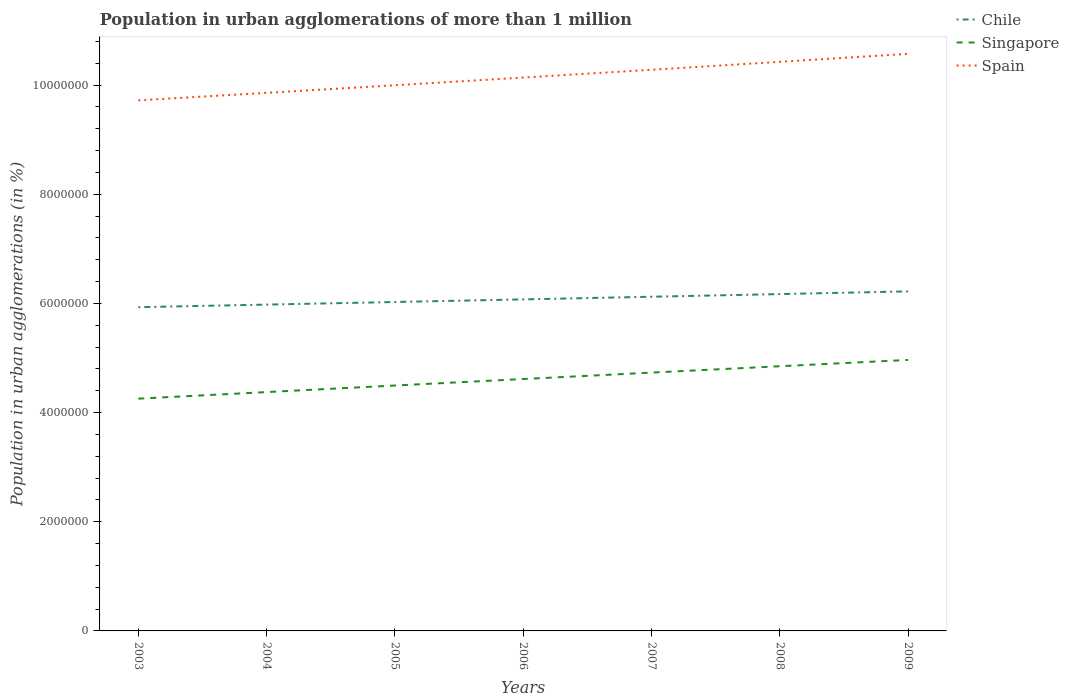How many different coloured lines are there?
Provide a succinct answer. 3. Across all years, what is the maximum population in urban agglomerations in Singapore?
Provide a succinct answer. 4.25e+06. In which year was the population in urban agglomerations in Singapore maximum?
Ensure brevity in your answer.  2003. What is the total population in urban agglomerations in Spain in the graph?
Provide a short and direct response. -5.68e+05. What is the difference between the highest and the second highest population in urban agglomerations in Spain?
Your response must be concise. 8.52e+05. What is the difference between the highest and the lowest population in urban agglomerations in Spain?
Your response must be concise. 3. Is the population in urban agglomerations in Chile strictly greater than the population in urban agglomerations in Spain over the years?
Offer a terse response. Yes. How many lines are there?
Offer a very short reply. 3. How many years are there in the graph?
Offer a very short reply. 7. What is the difference between two consecutive major ticks on the Y-axis?
Offer a very short reply. 2.00e+06. Are the values on the major ticks of Y-axis written in scientific E-notation?
Your answer should be compact. No. Does the graph contain grids?
Your answer should be very brief. No. How are the legend labels stacked?
Offer a very short reply. Vertical. What is the title of the graph?
Keep it short and to the point. Population in urban agglomerations of more than 1 million. Does "France" appear as one of the legend labels in the graph?
Offer a terse response. No. What is the label or title of the X-axis?
Offer a very short reply. Years. What is the label or title of the Y-axis?
Offer a very short reply. Population in urban agglomerations (in %). What is the Population in urban agglomerations (in %) in Chile in 2003?
Ensure brevity in your answer.  5.93e+06. What is the Population in urban agglomerations (in %) in Singapore in 2003?
Your answer should be very brief. 4.25e+06. What is the Population in urban agglomerations (in %) of Spain in 2003?
Make the answer very short. 9.72e+06. What is the Population in urban agglomerations (in %) of Chile in 2004?
Make the answer very short. 5.98e+06. What is the Population in urban agglomerations (in %) in Singapore in 2004?
Your answer should be very brief. 4.38e+06. What is the Population in urban agglomerations (in %) in Spain in 2004?
Provide a short and direct response. 9.86e+06. What is the Population in urban agglomerations (in %) of Chile in 2005?
Your answer should be very brief. 6.03e+06. What is the Population in urban agglomerations (in %) in Singapore in 2005?
Give a very brief answer. 4.50e+06. What is the Population in urban agglomerations (in %) of Spain in 2005?
Provide a succinct answer. 1.00e+07. What is the Population in urban agglomerations (in %) in Chile in 2006?
Your answer should be very brief. 6.07e+06. What is the Population in urban agglomerations (in %) in Singapore in 2006?
Keep it short and to the point. 4.61e+06. What is the Population in urban agglomerations (in %) in Spain in 2006?
Provide a succinct answer. 1.01e+07. What is the Population in urban agglomerations (in %) in Chile in 2007?
Give a very brief answer. 6.12e+06. What is the Population in urban agglomerations (in %) of Singapore in 2007?
Provide a succinct answer. 4.73e+06. What is the Population in urban agglomerations (in %) of Spain in 2007?
Your answer should be compact. 1.03e+07. What is the Population in urban agglomerations (in %) in Chile in 2008?
Provide a short and direct response. 6.17e+06. What is the Population in urban agglomerations (in %) in Singapore in 2008?
Provide a short and direct response. 4.85e+06. What is the Population in urban agglomerations (in %) in Spain in 2008?
Your answer should be very brief. 1.04e+07. What is the Population in urban agglomerations (in %) of Chile in 2009?
Provide a succinct answer. 6.22e+06. What is the Population in urban agglomerations (in %) of Singapore in 2009?
Give a very brief answer. 4.96e+06. What is the Population in urban agglomerations (in %) in Spain in 2009?
Provide a short and direct response. 1.06e+07. Across all years, what is the maximum Population in urban agglomerations (in %) of Chile?
Offer a terse response. 6.22e+06. Across all years, what is the maximum Population in urban agglomerations (in %) in Singapore?
Offer a very short reply. 4.96e+06. Across all years, what is the maximum Population in urban agglomerations (in %) in Spain?
Offer a terse response. 1.06e+07. Across all years, what is the minimum Population in urban agglomerations (in %) in Chile?
Provide a short and direct response. 5.93e+06. Across all years, what is the minimum Population in urban agglomerations (in %) in Singapore?
Offer a very short reply. 4.25e+06. Across all years, what is the minimum Population in urban agglomerations (in %) of Spain?
Offer a terse response. 9.72e+06. What is the total Population in urban agglomerations (in %) of Chile in the graph?
Offer a very short reply. 4.25e+07. What is the total Population in urban agglomerations (in %) of Singapore in the graph?
Your answer should be compact. 3.23e+07. What is the total Population in urban agglomerations (in %) of Spain in the graph?
Your answer should be compact. 7.10e+07. What is the difference between the Population in urban agglomerations (in %) in Chile in 2003 and that in 2004?
Keep it short and to the point. -4.73e+04. What is the difference between the Population in urban agglomerations (in %) in Singapore in 2003 and that in 2004?
Your answer should be compact. -1.21e+05. What is the difference between the Population in urban agglomerations (in %) in Spain in 2003 and that in 2004?
Your answer should be very brief. -1.37e+05. What is the difference between the Population in urban agglomerations (in %) of Chile in 2003 and that in 2005?
Your response must be concise. -9.49e+04. What is the difference between the Population in urban agglomerations (in %) of Singapore in 2003 and that in 2005?
Offer a terse response. -2.41e+05. What is the difference between the Population in urban agglomerations (in %) in Spain in 2003 and that in 2005?
Make the answer very short. -2.76e+05. What is the difference between the Population in urban agglomerations (in %) of Chile in 2003 and that in 2006?
Provide a short and direct response. -1.43e+05. What is the difference between the Population in urban agglomerations (in %) of Singapore in 2003 and that in 2006?
Keep it short and to the point. -3.60e+05. What is the difference between the Population in urban agglomerations (in %) in Spain in 2003 and that in 2006?
Make the answer very short. -4.17e+05. What is the difference between the Population in urban agglomerations (in %) in Chile in 2003 and that in 2007?
Offer a very short reply. -1.91e+05. What is the difference between the Population in urban agglomerations (in %) of Singapore in 2003 and that in 2007?
Your answer should be compact. -4.77e+05. What is the difference between the Population in urban agglomerations (in %) in Spain in 2003 and that in 2007?
Offer a terse response. -5.60e+05. What is the difference between the Population in urban agglomerations (in %) of Chile in 2003 and that in 2008?
Keep it short and to the point. -2.40e+05. What is the difference between the Population in urban agglomerations (in %) in Singapore in 2003 and that in 2008?
Offer a terse response. -5.94e+05. What is the difference between the Population in urban agglomerations (in %) of Spain in 2003 and that in 2008?
Keep it short and to the point. -7.05e+05. What is the difference between the Population in urban agglomerations (in %) of Chile in 2003 and that in 2009?
Ensure brevity in your answer.  -2.89e+05. What is the difference between the Population in urban agglomerations (in %) in Singapore in 2003 and that in 2009?
Keep it short and to the point. -7.10e+05. What is the difference between the Population in urban agglomerations (in %) in Spain in 2003 and that in 2009?
Your response must be concise. -8.52e+05. What is the difference between the Population in urban agglomerations (in %) in Chile in 2004 and that in 2005?
Your answer should be very brief. -4.76e+04. What is the difference between the Population in urban agglomerations (in %) of Singapore in 2004 and that in 2005?
Keep it short and to the point. -1.20e+05. What is the difference between the Population in urban agglomerations (in %) of Spain in 2004 and that in 2005?
Give a very brief answer. -1.39e+05. What is the difference between the Population in urban agglomerations (in %) in Chile in 2004 and that in 2006?
Your answer should be very brief. -9.56e+04. What is the difference between the Population in urban agglomerations (in %) of Singapore in 2004 and that in 2006?
Give a very brief answer. -2.39e+05. What is the difference between the Population in urban agglomerations (in %) of Spain in 2004 and that in 2006?
Offer a terse response. -2.80e+05. What is the difference between the Population in urban agglomerations (in %) of Chile in 2004 and that in 2007?
Offer a very short reply. -1.44e+05. What is the difference between the Population in urban agglomerations (in %) of Singapore in 2004 and that in 2007?
Keep it short and to the point. -3.57e+05. What is the difference between the Population in urban agglomerations (in %) in Spain in 2004 and that in 2007?
Offer a very short reply. -4.23e+05. What is the difference between the Population in urban agglomerations (in %) in Chile in 2004 and that in 2008?
Keep it short and to the point. -1.93e+05. What is the difference between the Population in urban agglomerations (in %) in Singapore in 2004 and that in 2008?
Make the answer very short. -4.73e+05. What is the difference between the Population in urban agglomerations (in %) of Spain in 2004 and that in 2008?
Provide a succinct answer. -5.68e+05. What is the difference between the Population in urban agglomerations (in %) of Chile in 2004 and that in 2009?
Offer a terse response. -2.42e+05. What is the difference between the Population in urban agglomerations (in %) in Singapore in 2004 and that in 2009?
Your answer should be compact. -5.89e+05. What is the difference between the Population in urban agglomerations (in %) in Spain in 2004 and that in 2009?
Ensure brevity in your answer.  -7.15e+05. What is the difference between the Population in urban agglomerations (in %) of Chile in 2005 and that in 2006?
Provide a succinct answer. -4.80e+04. What is the difference between the Population in urban agglomerations (in %) in Singapore in 2005 and that in 2006?
Offer a terse response. -1.19e+05. What is the difference between the Population in urban agglomerations (in %) in Spain in 2005 and that in 2006?
Provide a short and direct response. -1.41e+05. What is the difference between the Population in urban agglomerations (in %) of Chile in 2005 and that in 2007?
Your answer should be compact. -9.64e+04. What is the difference between the Population in urban agglomerations (in %) of Singapore in 2005 and that in 2007?
Your answer should be compact. -2.37e+05. What is the difference between the Population in urban agglomerations (in %) in Spain in 2005 and that in 2007?
Your answer should be very brief. -2.84e+05. What is the difference between the Population in urban agglomerations (in %) of Chile in 2005 and that in 2008?
Keep it short and to the point. -1.45e+05. What is the difference between the Population in urban agglomerations (in %) of Singapore in 2005 and that in 2008?
Make the answer very short. -3.53e+05. What is the difference between the Population in urban agglomerations (in %) of Spain in 2005 and that in 2008?
Provide a succinct answer. -4.29e+05. What is the difference between the Population in urban agglomerations (in %) of Chile in 2005 and that in 2009?
Give a very brief answer. -1.94e+05. What is the difference between the Population in urban agglomerations (in %) of Singapore in 2005 and that in 2009?
Provide a succinct answer. -4.69e+05. What is the difference between the Population in urban agglomerations (in %) in Spain in 2005 and that in 2009?
Offer a very short reply. -5.76e+05. What is the difference between the Population in urban agglomerations (in %) in Chile in 2006 and that in 2007?
Ensure brevity in your answer.  -4.84e+04. What is the difference between the Population in urban agglomerations (in %) of Singapore in 2006 and that in 2007?
Offer a terse response. -1.18e+05. What is the difference between the Population in urban agglomerations (in %) of Spain in 2006 and that in 2007?
Your answer should be compact. -1.43e+05. What is the difference between the Population in urban agglomerations (in %) in Chile in 2006 and that in 2008?
Provide a short and direct response. -9.73e+04. What is the difference between the Population in urban agglomerations (in %) in Singapore in 2006 and that in 2008?
Make the answer very short. -2.34e+05. What is the difference between the Population in urban agglomerations (in %) of Spain in 2006 and that in 2008?
Provide a succinct answer. -2.88e+05. What is the difference between the Population in urban agglomerations (in %) of Chile in 2006 and that in 2009?
Provide a succinct answer. -1.46e+05. What is the difference between the Population in urban agglomerations (in %) of Singapore in 2006 and that in 2009?
Make the answer very short. -3.50e+05. What is the difference between the Population in urban agglomerations (in %) in Spain in 2006 and that in 2009?
Your response must be concise. -4.35e+05. What is the difference between the Population in urban agglomerations (in %) in Chile in 2007 and that in 2008?
Offer a very short reply. -4.89e+04. What is the difference between the Population in urban agglomerations (in %) in Singapore in 2007 and that in 2008?
Provide a succinct answer. -1.17e+05. What is the difference between the Population in urban agglomerations (in %) in Spain in 2007 and that in 2008?
Your response must be concise. -1.45e+05. What is the difference between the Population in urban agglomerations (in %) in Chile in 2007 and that in 2009?
Your answer should be very brief. -9.80e+04. What is the difference between the Population in urban agglomerations (in %) of Singapore in 2007 and that in 2009?
Keep it short and to the point. -2.32e+05. What is the difference between the Population in urban agglomerations (in %) of Spain in 2007 and that in 2009?
Your answer should be compact. -2.92e+05. What is the difference between the Population in urban agglomerations (in %) of Chile in 2008 and that in 2009?
Ensure brevity in your answer.  -4.91e+04. What is the difference between the Population in urban agglomerations (in %) in Singapore in 2008 and that in 2009?
Ensure brevity in your answer.  -1.16e+05. What is the difference between the Population in urban agglomerations (in %) in Spain in 2008 and that in 2009?
Make the answer very short. -1.47e+05. What is the difference between the Population in urban agglomerations (in %) of Chile in 2003 and the Population in urban agglomerations (in %) of Singapore in 2004?
Your answer should be compact. 1.56e+06. What is the difference between the Population in urban agglomerations (in %) of Chile in 2003 and the Population in urban agglomerations (in %) of Spain in 2004?
Ensure brevity in your answer.  -3.93e+06. What is the difference between the Population in urban agglomerations (in %) of Singapore in 2003 and the Population in urban agglomerations (in %) of Spain in 2004?
Offer a terse response. -5.60e+06. What is the difference between the Population in urban agglomerations (in %) of Chile in 2003 and the Population in urban agglomerations (in %) of Singapore in 2005?
Keep it short and to the point. 1.43e+06. What is the difference between the Population in urban agglomerations (in %) in Chile in 2003 and the Population in urban agglomerations (in %) in Spain in 2005?
Your response must be concise. -4.07e+06. What is the difference between the Population in urban agglomerations (in %) in Singapore in 2003 and the Population in urban agglomerations (in %) in Spain in 2005?
Provide a succinct answer. -5.74e+06. What is the difference between the Population in urban agglomerations (in %) of Chile in 2003 and the Population in urban agglomerations (in %) of Singapore in 2006?
Your response must be concise. 1.32e+06. What is the difference between the Population in urban agglomerations (in %) in Chile in 2003 and the Population in urban agglomerations (in %) in Spain in 2006?
Give a very brief answer. -4.21e+06. What is the difference between the Population in urban agglomerations (in %) in Singapore in 2003 and the Population in urban agglomerations (in %) in Spain in 2006?
Offer a terse response. -5.88e+06. What is the difference between the Population in urban agglomerations (in %) of Chile in 2003 and the Population in urban agglomerations (in %) of Singapore in 2007?
Offer a very short reply. 1.20e+06. What is the difference between the Population in urban agglomerations (in %) of Chile in 2003 and the Population in urban agglomerations (in %) of Spain in 2007?
Make the answer very short. -4.35e+06. What is the difference between the Population in urban agglomerations (in %) of Singapore in 2003 and the Population in urban agglomerations (in %) of Spain in 2007?
Keep it short and to the point. -6.02e+06. What is the difference between the Population in urban agglomerations (in %) in Chile in 2003 and the Population in urban agglomerations (in %) in Singapore in 2008?
Your answer should be very brief. 1.08e+06. What is the difference between the Population in urban agglomerations (in %) in Chile in 2003 and the Population in urban agglomerations (in %) in Spain in 2008?
Your answer should be very brief. -4.49e+06. What is the difference between the Population in urban agglomerations (in %) in Singapore in 2003 and the Population in urban agglomerations (in %) in Spain in 2008?
Give a very brief answer. -6.17e+06. What is the difference between the Population in urban agglomerations (in %) of Chile in 2003 and the Population in urban agglomerations (in %) of Singapore in 2009?
Provide a succinct answer. 9.66e+05. What is the difference between the Population in urban agglomerations (in %) in Chile in 2003 and the Population in urban agglomerations (in %) in Spain in 2009?
Offer a terse response. -4.64e+06. What is the difference between the Population in urban agglomerations (in %) of Singapore in 2003 and the Population in urban agglomerations (in %) of Spain in 2009?
Offer a terse response. -6.32e+06. What is the difference between the Population in urban agglomerations (in %) of Chile in 2004 and the Population in urban agglomerations (in %) of Singapore in 2005?
Provide a succinct answer. 1.48e+06. What is the difference between the Population in urban agglomerations (in %) in Chile in 2004 and the Population in urban agglomerations (in %) in Spain in 2005?
Ensure brevity in your answer.  -4.02e+06. What is the difference between the Population in urban agglomerations (in %) in Singapore in 2004 and the Population in urban agglomerations (in %) in Spain in 2005?
Your answer should be very brief. -5.62e+06. What is the difference between the Population in urban agglomerations (in %) of Chile in 2004 and the Population in urban agglomerations (in %) of Singapore in 2006?
Make the answer very short. 1.36e+06. What is the difference between the Population in urban agglomerations (in %) in Chile in 2004 and the Population in urban agglomerations (in %) in Spain in 2006?
Provide a succinct answer. -4.16e+06. What is the difference between the Population in urban agglomerations (in %) in Singapore in 2004 and the Population in urban agglomerations (in %) in Spain in 2006?
Ensure brevity in your answer.  -5.76e+06. What is the difference between the Population in urban agglomerations (in %) of Chile in 2004 and the Population in urban agglomerations (in %) of Singapore in 2007?
Offer a very short reply. 1.25e+06. What is the difference between the Population in urban agglomerations (in %) of Chile in 2004 and the Population in urban agglomerations (in %) of Spain in 2007?
Provide a succinct answer. -4.30e+06. What is the difference between the Population in urban agglomerations (in %) of Singapore in 2004 and the Population in urban agglomerations (in %) of Spain in 2007?
Ensure brevity in your answer.  -5.90e+06. What is the difference between the Population in urban agglomerations (in %) of Chile in 2004 and the Population in urban agglomerations (in %) of Singapore in 2008?
Make the answer very short. 1.13e+06. What is the difference between the Population in urban agglomerations (in %) of Chile in 2004 and the Population in urban agglomerations (in %) of Spain in 2008?
Your response must be concise. -4.45e+06. What is the difference between the Population in urban agglomerations (in %) in Singapore in 2004 and the Population in urban agglomerations (in %) in Spain in 2008?
Offer a very short reply. -6.05e+06. What is the difference between the Population in urban agglomerations (in %) in Chile in 2004 and the Population in urban agglomerations (in %) in Singapore in 2009?
Your response must be concise. 1.01e+06. What is the difference between the Population in urban agglomerations (in %) of Chile in 2004 and the Population in urban agglomerations (in %) of Spain in 2009?
Make the answer very short. -4.59e+06. What is the difference between the Population in urban agglomerations (in %) in Singapore in 2004 and the Population in urban agglomerations (in %) in Spain in 2009?
Keep it short and to the point. -6.20e+06. What is the difference between the Population in urban agglomerations (in %) in Chile in 2005 and the Population in urban agglomerations (in %) in Singapore in 2006?
Keep it short and to the point. 1.41e+06. What is the difference between the Population in urban agglomerations (in %) of Chile in 2005 and the Population in urban agglomerations (in %) of Spain in 2006?
Offer a terse response. -4.11e+06. What is the difference between the Population in urban agglomerations (in %) in Singapore in 2005 and the Population in urban agglomerations (in %) in Spain in 2006?
Ensure brevity in your answer.  -5.64e+06. What is the difference between the Population in urban agglomerations (in %) of Chile in 2005 and the Population in urban agglomerations (in %) of Singapore in 2007?
Provide a short and direct response. 1.29e+06. What is the difference between the Population in urban agglomerations (in %) of Chile in 2005 and the Population in urban agglomerations (in %) of Spain in 2007?
Offer a very short reply. -4.25e+06. What is the difference between the Population in urban agglomerations (in %) in Singapore in 2005 and the Population in urban agglomerations (in %) in Spain in 2007?
Your answer should be compact. -5.78e+06. What is the difference between the Population in urban agglomerations (in %) of Chile in 2005 and the Population in urban agglomerations (in %) of Singapore in 2008?
Your response must be concise. 1.18e+06. What is the difference between the Population in urban agglomerations (in %) in Chile in 2005 and the Population in urban agglomerations (in %) in Spain in 2008?
Provide a succinct answer. -4.40e+06. What is the difference between the Population in urban agglomerations (in %) of Singapore in 2005 and the Population in urban agglomerations (in %) of Spain in 2008?
Offer a very short reply. -5.93e+06. What is the difference between the Population in urban agglomerations (in %) in Chile in 2005 and the Population in urban agglomerations (in %) in Singapore in 2009?
Provide a short and direct response. 1.06e+06. What is the difference between the Population in urban agglomerations (in %) in Chile in 2005 and the Population in urban agglomerations (in %) in Spain in 2009?
Your response must be concise. -4.55e+06. What is the difference between the Population in urban agglomerations (in %) in Singapore in 2005 and the Population in urban agglomerations (in %) in Spain in 2009?
Your answer should be compact. -6.08e+06. What is the difference between the Population in urban agglomerations (in %) in Chile in 2006 and the Population in urban agglomerations (in %) in Singapore in 2007?
Keep it short and to the point. 1.34e+06. What is the difference between the Population in urban agglomerations (in %) of Chile in 2006 and the Population in urban agglomerations (in %) of Spain in 2007?
Your answer should be very brief. -4.21e+06. What is the difference between the Population in urban agglomerations (in %) in Singapore in 2006 and the Population in urban agglomerations (in %) in Spain in 2007?
Provide a succinct answer. -5.67e+06. What is the difference between the Population in urban agglomerations (in %) of Chile in 2006 and the Population in urban agglomerations (in %) of Singapore in 2008?
Offer a very short reply. 1.22e+06. What is the difference between the Population in urban agglomerations (in %) of Chile in 2006 and the Population in urban agglomerations (in %) of Spain in 2008?
Offer a terse response. -4.35e+06. What is the difference between the Population in urban agglomerations (in %) in Singapore in 2006 and the Population in urban agglomerations (in %) in Spain in 2008?
Give a very brief answer. -5.81e+06. What is the difference between the Population in urban agglomerations (in %) of Chile in 2006 and the Population in urban agglomerations (in %) of Singapore in 2009?
Provide a short and direct response. 1.11e+06. What is the difference between the Population in urban agglomerations (in %) in Chile in 2006 and the Population in urban agglomerations (in %) in Spain in 2009?
Ensure brevity in your answer.  -4.50e+06. What is the difference between the Population in urban agglomerations (in %) of Singapore in 2006 and the Population in urban agglomerations (in %) of Spain in 2009?
Keep it short and to the point. -5.96e+06. What is the difference between the Population in urban agglomerations (in %) in Chile in 2007 and the Population in urban agglomerations (in %) in Singapore in 2008?
Keep it short and to the point. 1.27e+06. What is the difference between the Population in urban agglomerations (in %) of Chile in 2007 and the Population in urban agglomerations (in %) of Spain in 2008?
Keep it short and to the point. -4.30e+06. What is the difference between the Population in urban agglomerations (in %) in Singapore in 2007 and the Population in urban agglomerations (in %) in Spain in 2008?
Provide a short and direct response. -5.69e+06. What is the difference between the Population in urban agglomerations (in %) in Chile in 2007 and the Population in urban agglomerations (in %) in Singapore in 2009?
Your answer should be compact. 1.16e+06. What is the difference between the Population in urban agglomerations (in %) of Chile in 2007 and the Population in urban agglomerations (in %) of Spain in 2009?
Offer a terse response. -4.45e+06. What is the difference between the Population in urban agglomerations (in %) of Singapore in 2007 and the Population in urban agglomerations (in %) of Spain in 2009?
Your answer should be compact. -5.84e+06. What is the difference between the Population in urban agglomerations (in %) in Chile in 2008 and the Population in urban agglomerations (in %) in Singapore in 2009?
Keep it short and to the point. 1.21e+06. What is the difference between the Population in urban agglomerations (in %) in Chile in 2008 and the Population in urban agglomerations (in %) in Spain in 2009?
Ensure brevity in your answer.  -4.40e+06. What is the difference between the Population in urban agglomerations (in %) of Singapore in 2008 and the Population in urban agglomerations (in %) of Spain in 2009?
Give a very brief answer. -5.72e+06. What is the average Population in urban agglomerations (in %) of Chile per year?
Provide a short and direct response. 6.07e+06. What is the average Population in urban agglomerations (in %) of Singapore per year?
Offer a terse response. 4.61e+06. What is the average Population in urban agglomerations (in %) of Spain per year?
Your response must be concise. 1.01e+07. In the year 2003, what is the difference between the Population in urban agglomerations (in %) in Chile and Population in urban agglomerations (in %) in Singapore?
Make the answer very short. 1.68e+06. In the year 2003, what is the difference between the Population in urban agglomerations (in %) in Chile and Population in urban agglomerations (in %) in Spain?
Offer a terse response. -3.79e+06. In the year 2003, what is the difference between the Population in urban agglomerations (in %) of Singapore and Population in urban agglomerations (in %) of Spain?
Ensure brevity in your answer.  -5.46e+06. In the year 2004, what is the difference between the Population in urban agglomerations (in %) in Chile and Population in urban agglomerations (in %) in Singapore?
Provide a succinct answer. 1.60e+06. In the year 2004, what is the difference between the Population in urban agglomerations (in %) of Chile and Population in urban agglomerations (in %) of Spain?
Make the answer very short. -3.88e+06. In the year 2004, what is the difference between the Population in urban agglomerations (in %) of Singapore and Population in urban agglomerations (in %) of Spain?
Offer a terse response. -5.48e+06. In the year 2005, what is the difference between the Population in urban agglomerations (in %) of Chile and Population in urban agglomerations (in %) of Singapore?
Provide a short and direct response. 1.53e+06. In the year 2005, what is the difference between the Population in urban agglomerations (in %) of Chile and Population in urban agglomerations (in %) of Spain?
Ensure brevity in your answer.  -3.97e+06. In the year 2005, what is the difference between the Population in urban agglomerations (in %) in Singapore and Population in urban agglomerations (in %) in Spain?
Provide a short and direct response. -5.50e+06. In the year 2006, what is the difference between the Population in urban agglomerations (in %) of Chile and Population in urban agglomerations (in %) of Singapore?
Offer a very short reply. 1.46e+06. In the year 2006, what is the difference between the Population in urban agglomerations (in %) of Chile and Population in urban agglomerations (in %) of Spain?
Make the answer very short. -4.06e+06. In the year 2006, what is the difference between the Population in urban agglomerations (in %) in Singapore and Population in urban agglomerations (in %) in Spain?
Keep it short and to the point. -5.52e+06. In the year 2007, what is the difference between the Population in urban agglomerations (in %) of Chile and Population in urban agglomerations (in %) of Singapore?
Your answer should be compact. 1.39e+06. In the year 2007, what is the difference between the Population in urban agglomerations (in %) of Chile and Population in urban agglomerations (in %) of Spain?
Your answer should be compact. -4.16e+06. In the year 2007, what is the difference between the Population in urban agglomerations (in %) of Singapore and Population in urban agglomerations (in %) of Spain?
Your response must be concise. -5.55e+06. In the year 2008, what is the difference between the Population in urban agglomerations (in %) of Chile and Population in urban agglomerations (in %) of Singapore?
Ensure brevity in your answer.  1.32e+06. In the year 2008, what is the difference between the Population in urban agglomerations (in %) of Chile and Population in urban agglomerations (in %) of Spain?
Your answer should be compact. -4.25e+06. In the year 2008, what is the difference between the Population in urban agglomerations (in %) in Singapore and Population in urban agglomerations (in %) in Spain?
Provide a succinct answer. -5.58e+06. In the year 2009, what is the difference between the Population in urban agglomerations (in %) in Chile and Population in urban agglomerations (in %) in Singapore?
Provide a short and direct response. 1.26e+06. In the year 2009, what is the difference between the Population in urban agglomerations (in %) of Chile and Population in urban agglomerations (in %) of Spain?
Your response must be concise. -4.35e+06. In the year 2009, what is the difference between the Population in urban agglomerations (in %) of Singapore and Population in urban agglomerations (in %) of Spain?
Ensure brevity in your answer.  -5.61e+06. What is the ratio of the Population in urban agglomerations (in %) of Chile in 2003 to that in 2004?
Give a very brief answer. 0.99. What is the ratio of the Population in urban agglomerations (in %) of Singapore in 2003 to that in 2004?
Ensure brevity in your answer.  0.97. What is the ratio of the Population in urban agglomerations (in %) of Spain in 2003 to that in 2004?
Ensure brevity in your answer.  0.99. What is the ratio of the Population in urban agglomerations (in %) in Chile in 2003 to that in 2005?
Give a very brief answer. 0.98. What is the ratio of the Population in urban agglomerations (in %) of Singapore in 2003 to that in 2005?
Ensure brevity in your answer.  0.95. What is the ratio of the Population in urban agglomerations (in %) in Spain in 2003 to that in 2005?
Your response must be concise. 0.97. What is the ratio of the Population in urban agglomerations (in %) of Chile in 2003 to that in 2006?
Keep it short and to the point. 0.98. What is the ratio of the Population in urban agglomerations (in %) in Singapore in 2003 to that in 2006?
Offer a very short reply. 0.92. What is the ratio of the Population in urban agglomerations (in %) of Spain in 2003 to that in 2006?
Your answer should be very brief. 0.96. What is the ratio of the Population in urban agglomerations (in %) in Chile in 2003 to that in 2007?
Provide a short and direct response. 0.97. What is the ratio of the Population in urban agglomerations (in %) of Singapore in 2003 to that in 2007?
Offer a very short reply. 0.9. What is the ratio of the Population in urban agglomerations (in %) of Spain in 2003 to that in 2007?
Offer a very short reply. 0.95. What is the ratio of the Population in urban agglomerations (in %) of Chile in 2003 to that in 2008?
Your answer should be compact. 0.96. What is the ratio of the Population in urban agglomerations (in %) of Singapore in 2003 to that in 2008?
Give a very brief answer. 0.88. What is the ratio of the Population in urban agglomerations (in %) of Spain in 2003 to that in 2008?
Provide a succinct answer. 0.93. What is the ratio of the Population in urban agglomerations (in %) in Chile in 2003 to that in 2009?
Provide a succinct answer. 0.95. What is the ratio of the Population in urban agglomerations (in %) of Spain in 2003 to that in 2009?
Offer a terse response. 0.92. What is the ratio of the Population in urban agglomerations (in %) in Chile in 2004 to that in 2005?
Offer a very short reply. 0.99. What is the ratio of the Population in urban agglomerations (in %) in Singapore in 2004 to that in 2005?
Your response must be concise. 0.97. What is the ratio of the Population in urban agglomerations (in %) in Spain in 2004 to that in 2005?
Your answer should be very brief. 0.99. What is the ratio of the Population in urban agglomerations (in %) of Chile in 2004 to that in 2006?
Ensure brevity in your answer.  0.98. What is the ratio of the Population in urban agglomerations (in %) in Singapore in 2004 to that in 2006?
Ensure brevity in your answer.  0.95. What is the ratio of the Population in urban agglomerations (in %) in Spain in 2004 to that in 2006?
Keep it short and to the point. 0.97. What is the ratio of the Population in urban agglomerations (in %) of Chile in 2004 to that in 2007?
Keep it short and to the point. 0.98. What is the ratio of the Population in urban agglomerations (in %) of Singapore in 2004 to that in 2007?
Provide a succinct answer. 0.92. What is the ratio of the Population in urban agglomerations (in %) in Spain in 2004 to that in 2007?
Offer a very short reply. 0.96. What is the ratio of the Population in urban agglomerations (in %) of Chile in 2004 to that in 2008?
Give a very brief answer. 0.97. What is the ratio of the Population in urban agglomerations (in %) in Singapore in 2004 to that in 2008?
Keep it short and to the point. 0.9. What is the ratio of the Population in urban agglomerations (in %) in Spain in 2004 to that in 2008?
Ensure brevity in your answer.  0.95. What is the ratio of the Population in urban agglomerations (in %) in Chile in 2004 to that in 2009?
Provide a short and direct response. 0.96. What is the ratio of the Population in urban agglomerations (in %) in Singapore in 2004 to that in 2009?
Your answer should be compact. 0.88. What is the ratio of the Population in urban agglomerations (in %) of Spain in 2004 to that in 2009?
Offer a terse response. 0.93. What is the ratio of the Population in urban agglomerations (in %) in Singapore in 2005 to that in 2006?
Provide a succinct answer. 0.97. What is the ratio of the Population in urban agglomerations (in %) of Spain in 2005 to that in 2006?
Your answer should be compact. 0.99. What is the ratio of the Population in urban agglomerations (in %) in Chile in 2005 to that in 2007?
Your answer should be compact. 0.98. What is the ratio of the Population in urban agglomerations (in %) of Spain in 2005 to that in 2007?
Your response must be concise. 0.97. What is the ratio of the Population in urban agglomerations (in %) of Chile in 2005 to that in 2008?
Your answer should be compact. 0.98. What is the ratio of the Population in urban agglomerations (in %) in Singapore in 2005 to that in 2008?
Make the answer very short. 0.93. What is the ratio of the Population in urban agglomerations (in %) in Spain in 2005 to that in 2008?
Ensure brevity in your answer.  0.96. What is the ratio of the Population in urban agglomerations (in %) in Chile in 2005 to that in 2009?
Keep it short and to the point. 0.97. What is the ratio of the Population in urban agglomerations (in %) in Singapore in 2005 to that in 2009?
Offer a terse response. 0.91. What is the ratio of the Population in urban agglomerations (in %) of Spain in 2005 to that in 2009?
Make the answer very short. 0.95. What is the ratio of the Population in urban agglomerations (in %) of Chile in 2006 to that in 2007?
Provide a succinct answer. 0.99. What is the ratio of the Population in urban agglomerations (in %) in Singapore in 2006 to that in 2007?
Your answer should be very brief. 0.98. What is the ratio of the Population in urban agglomerations (in %) in Spain in 2006 to that in 2007?
Ensure brevity in your answer.  0.99. What is the ratio of the Population in urban agglomerations (in %) in Chile in 2006 to that in 2008?
Provide a succinct answer. 0.98. What is the ratio of the Population in urban agglomerations (in %) of Singapore in 2006 to that in 2008?
Offer a terse response. 0.95. What is the ratio of the Population in urban agglomerations (in %) in Spain in 2006 to that in 2008?
Give a very brief answer. 0.97. What is the ratio of the Population in urban agglomerations (in %) of Chile in 2006 to that in 2009?
Give a very brief answer. 0.98. What is the ratio of the Population in urban agglomerations (in %) of Singapore in 2006 to that in 2009?
Your answer should be very brief. 0.93. What is the ratio of the Population in urban agglomerations (in %) in Spain in 2006 to that in 2009?
Provide a succinct answer. 0.96. What is the ratio of the Population in urban agglomerations (in %) of Singapore in 2007 to that in 2008?
Your response must be concise. 0.98. What is the ratio of the Population in urban agglomerations (in %) of Spain in 2007 to that in 2008?
Offer a very short reply. 0.99. What is the ratio of the Population in urban agglomerations (in %) of Chile in 2007 to that in 2009?
Ensure brevity in your answer.  0.98. What is the ratio of the Population in urban agglomerations (in %) in Singapore in 2007 to that in 2009?
Your response must be concise. 0.95. What is the ratio of the Population in urban agglomerations (in %) of Spain in 2007 to that in 2009?
Provide a short and direct response. 0.97. What is the ratio of the Population in urban agglomerations (in %) in Singapore in 2008 to that in 2009?
Your response must be concise. 0.98. What is the ratio of the Population in urban agglomerations (in %) of Spain in 2008 to that in 2009?
Your answer should be very brief. 0.99. What is the difference between the highest and the second highest Population in urban agglomerations (in %) in Chile?
Your response must be concise. 4.91e+04. What is the difference between the highest and the second highest Population in urban agglomerations (in %) of Singapore?
Give a very brief answer. 1.16e+05. What is the difference between the highest and the second highest Population in urban agglomerations (in %) in Spain?
Provide a succinct answer. 1.47e+05. What is the difference between the highest and the lowest Population in urban agglomerations (in %) in Chile?
Offer a very short reply. 2.89e+05. What is the difference between the highest and the lowest Population in urban agglomerations (in %) in Singapore?
Provide a succinct answer. 7.10e+05. What is the difference between the highest and the lowest Population in urban agglomerations (in %) of Spain?
Your answer should be very brief. 8.52e+05. 